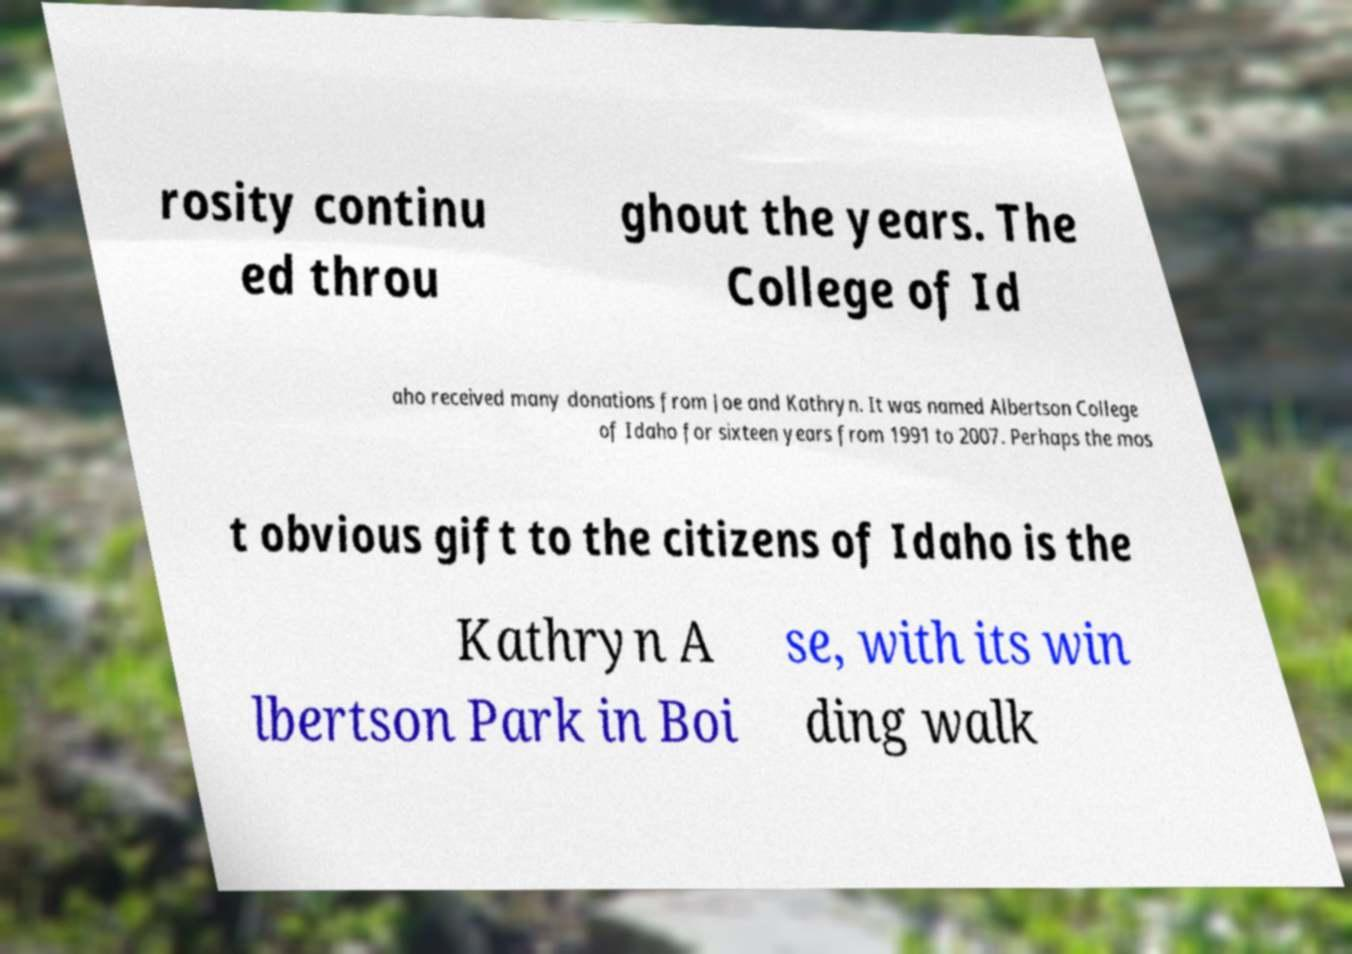Can you read and provide the text displayed in the image?This photo seems to have some interesting text. Can you extract and type it out for me? rosity continu ed throu ghout the years. The College of Id aho received many donations from Joe and Kathryn. It was named Albertson College of Idaho for sixteen years from 1991 to 2007. Perhaps the mos t obvious gift to the citizens of Idaho is the Kathryn A lbertson Park in Boi se, with its win ding walk 